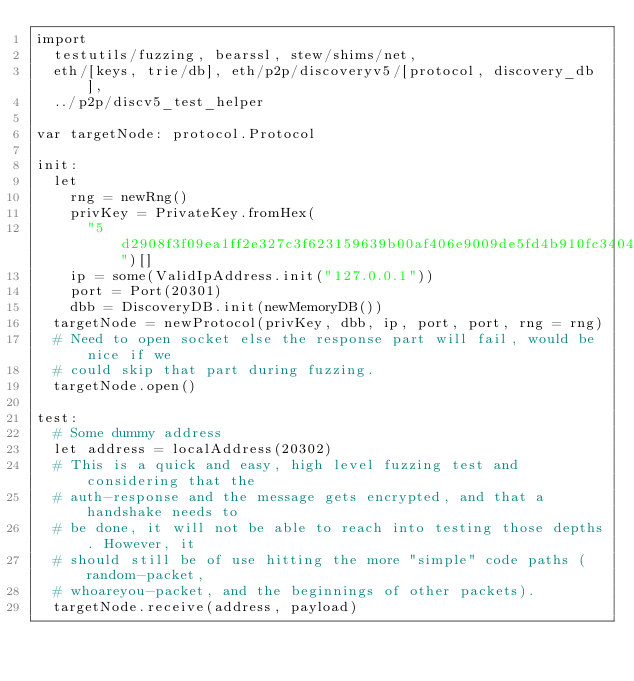<code> <loc_0><loc_0><loc_500><loc_500><_Nim_>import
  testutils/fuzzing, bearssl, stew/shims/net,
  eth/[keys, trie/db], eth/p2p/discoveryv5/[protocol, discovery_db],
  ../p2p/discv5_test_helper

var targetNode: protocol.Protocol

init:
  let
    rng = newRng()
    privKey = PrivateKey.fromHex(
      "5d2908f3f09ea1ff2e327c3f623159639b00af406e9009de5fd4b910fc34049d")[]
    ip = some(ValidIpAddress.init("127.0.0.1"))
    port = Port(20301)
    dbb = DiscoveryDB.init(newMemoryDB())
  targetNode = newProtocol(privKey, dbb, ip, port, port, rng = rng)
  # Need to open socket else the response part will fail, would be nice if we
  # could skip that part during fuzzing.
  targetNode.open()

test:
  # Some dummy address
  let address = localAddress(20302)
  # This is a quick and easy, high level fuzzing test and considering that the
  # auth-response and the message gets encrypted, and that a handshake needs to
  # be done, it will not be able to reach into testing those depths. However, it
  # should still be of use hitting the more "simple" code paths (random-packet,
  # whoareyou-packet, and the beginnings of other packets).
  targetNode.receive(address, payload)
</code> 